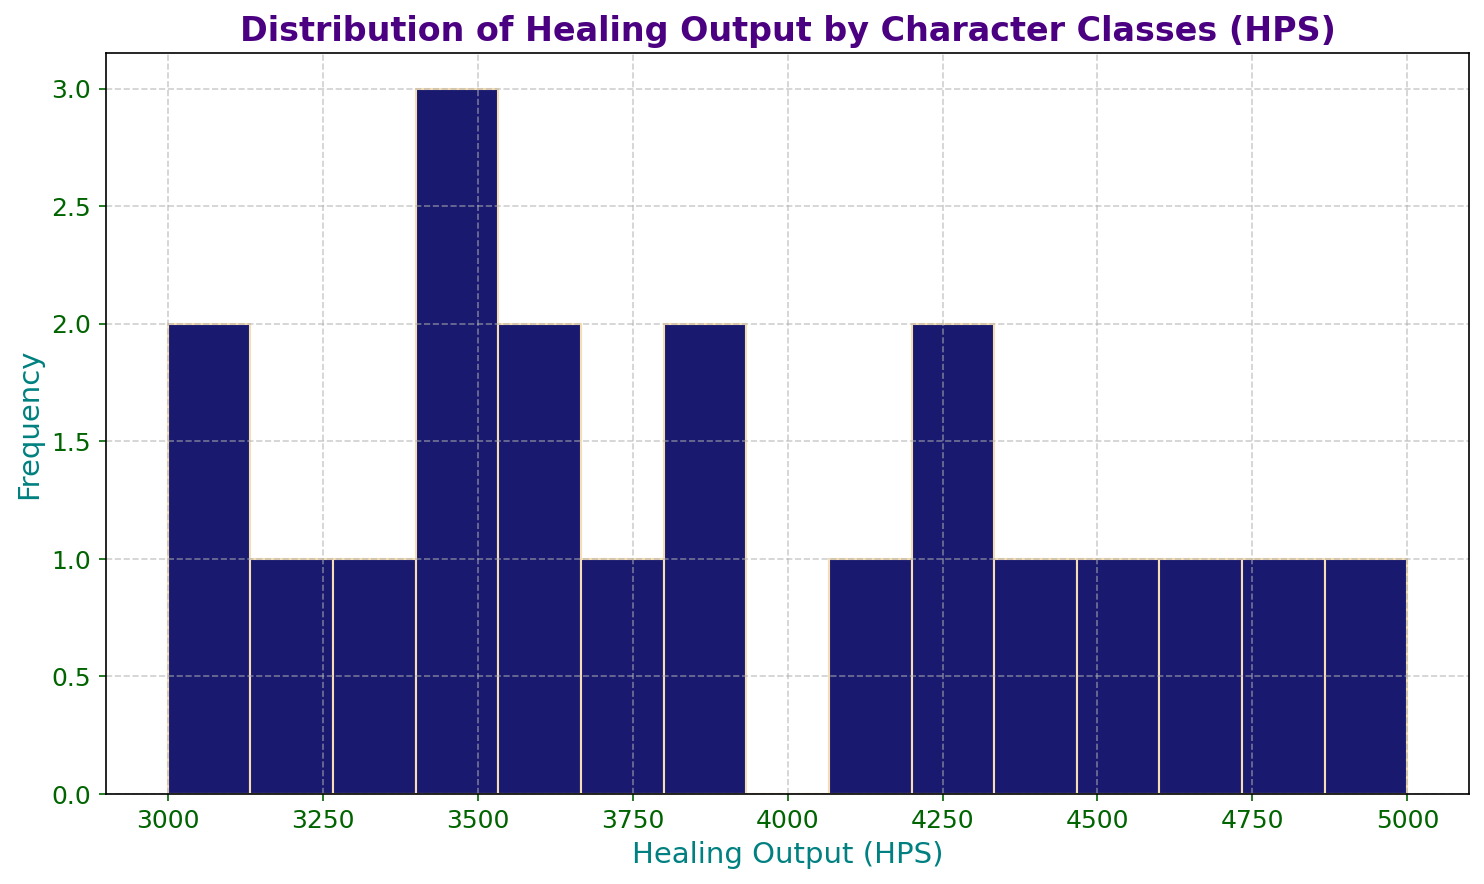What is the most frequent range of healing output in the histogram? Identify the bar in the histogram that is the tallest, as the height of a bar represents the frequency of healing outputs in that range.
Answer: 3000-3500 HPS Which character class has a healing output that falls in the range 4500-5000 HPS? Look at the bins representing the range 4500-5000 HPS, then refer to the data to identify the classes in that range.
Answer: Cleric, Priest, Mistweaver, WhiteMage How many character classes have a healing output less than 3500 HPS? Count the bins, and their respective classes, with healing outputs less than 3500 HPS.
Answer: 4 classes (Chaplain, Druid from Game C, Templar, Bard) Which game has the highest average healing output? Calculate the average healing output for each game by summing up the healing outputs of all classes for a game and dividing by the number of classes in that game. Compare the averages.
Answer: GameB Is the frequency of healing output in the 4000-4500 HPS range greater or less than that in the 3000-3500 HPS range? Compare the heights of the bars representing the ranges 4000-4500 HPS and 3000-3500 HPS. The taller bar corresponds to a higher frequency.
Answer: Less Which character class from Game D has the highest healing output? Refer to the data for Game D and identify the class with the highest healing output.
Answer: Alchemist What is the total frequency of healing outputs in the range 4500-5000 HPS compared to the range 3000-3500 HPS? Count the total number of classes in the 4500-5000 HPS range and compare it with the number of classes in the 3000-3500 HPS range.
Answer: Same What is the range of the bars with the lowest frequency? Identify the shortest bars in the histogram and determine their corresponding healing output ranges.
Answer: 3500-4000 HPS How much higher is the healing output of the highest class compared to the lowest class? Identify the classes with the highest and lowest healing outputs and calculate the difference.
Answer: 5000 - 3100 = 1900 HPS 